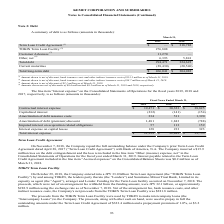According to Kemet Corporation's financial document, What was the amount of discount for Customer Advances? According to the financial document, 2.1 (in millions). The relevant text states: "31, 2019. (3) Amount shown is net of discount of $2.1 million as of March 31, 2019. (4) Amounts shown are net of discounts of $0.6 million and $0.5 milli..." Also, What was the Term Loan Credit Agreement  in 2018? According to the financial document, 318,782 (in thousands). The relevant text states: "Term Loan Credit Agreement (1) $ — $ 318,782..." Also, Which years does the table provide information for the company's summary of debt? The document shows two values: 2019 and 2018. From the document: "2019 2018 2019 2018..." Also, can you calculate: What was the change in Total debt between 2018 and 2019? Based on the calculation: 294,471-324,623, the result is -30152 (in thousands). This is based on the information: "Total debt 294,471 324,623 Total debt 294,471 324,623..." The key data points involved are: 294,471, 324,623. Also, can you calculate: What was the change in current maturities between 2018 and 2019? Based on the calculation: -28,430-(-20,540), the result is -7890 (in thousands). This is based on the information: "Current maturities (28,430) (20,540) Current maturities (28,430) (20,540)..." The key data points involved are: 20,540, 28,430. Also, can you calculate: What was the percentage change in total long-term debt between 2018 and 2019? To answer this question, I need to perform calculations using the financial data. The calculation is: (266,041-304,083)/304,083, which equals -12.51 (percentage). This is based on the information: "Total long-term debt $ 266,041 $ 304,083 Total long-term debt $ 266,041 $ 304,083..." The key data points involved are: 266,041, 304,083. 